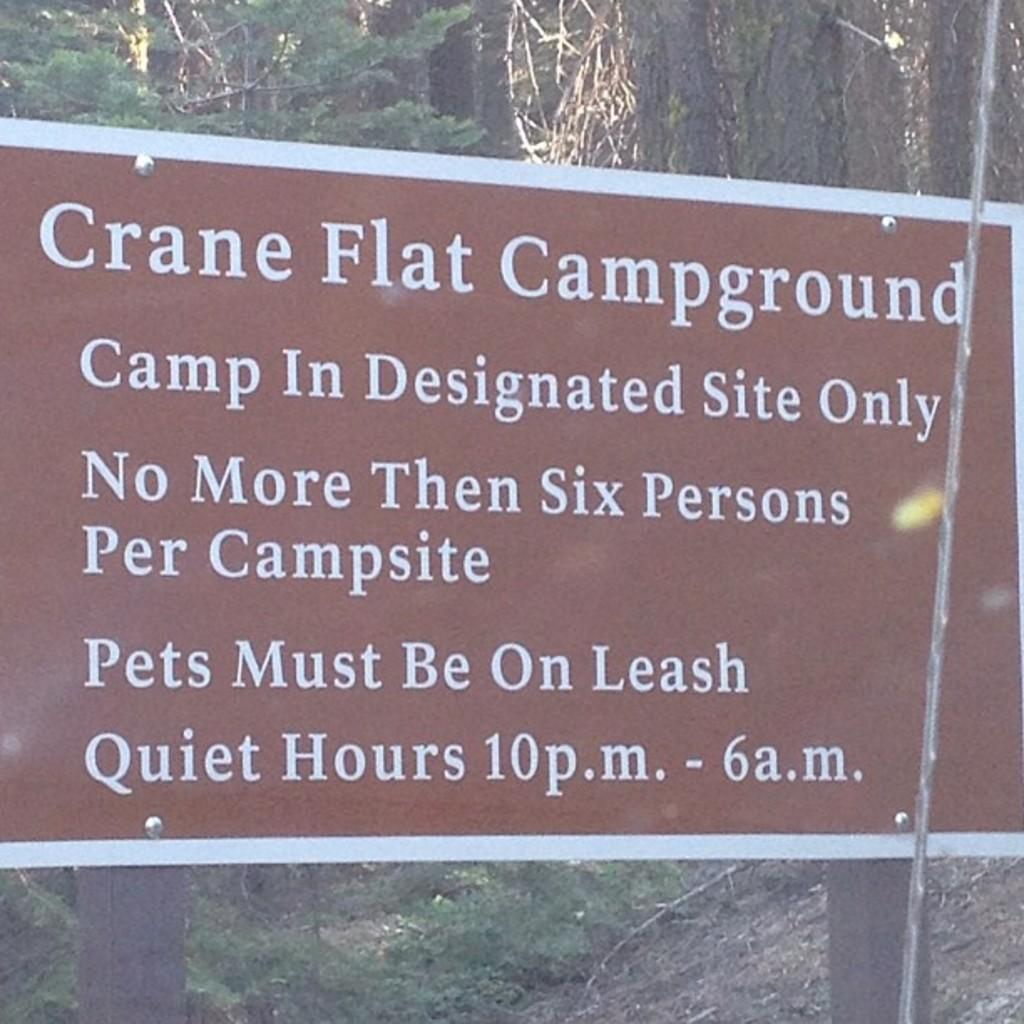Could you give a brief overview of what you see in this image? In the image there is a name board in the front and behind it there are trees on the land. 